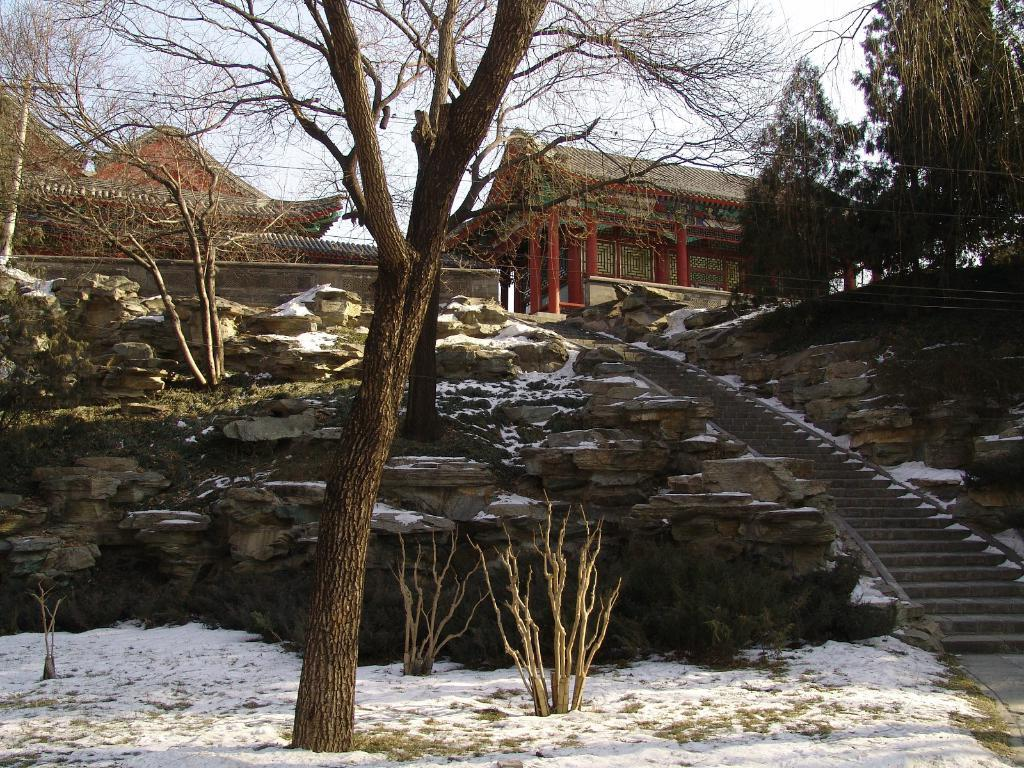What can be seen in the image that people use to move between different levels? There are stairs in the image that people use to move between different levels. What type of natural elements are present near the stairs? There are trees and rocks to the side of the stairs. What type of structures can be seen in the background of the image? There are huts in the background of the image. What is visible in the sky in the image? The sky is visible in the background of the image. What type of cart is being used to transport the list and uncle in the image? There is no cart, list, or uncle present in the image. 